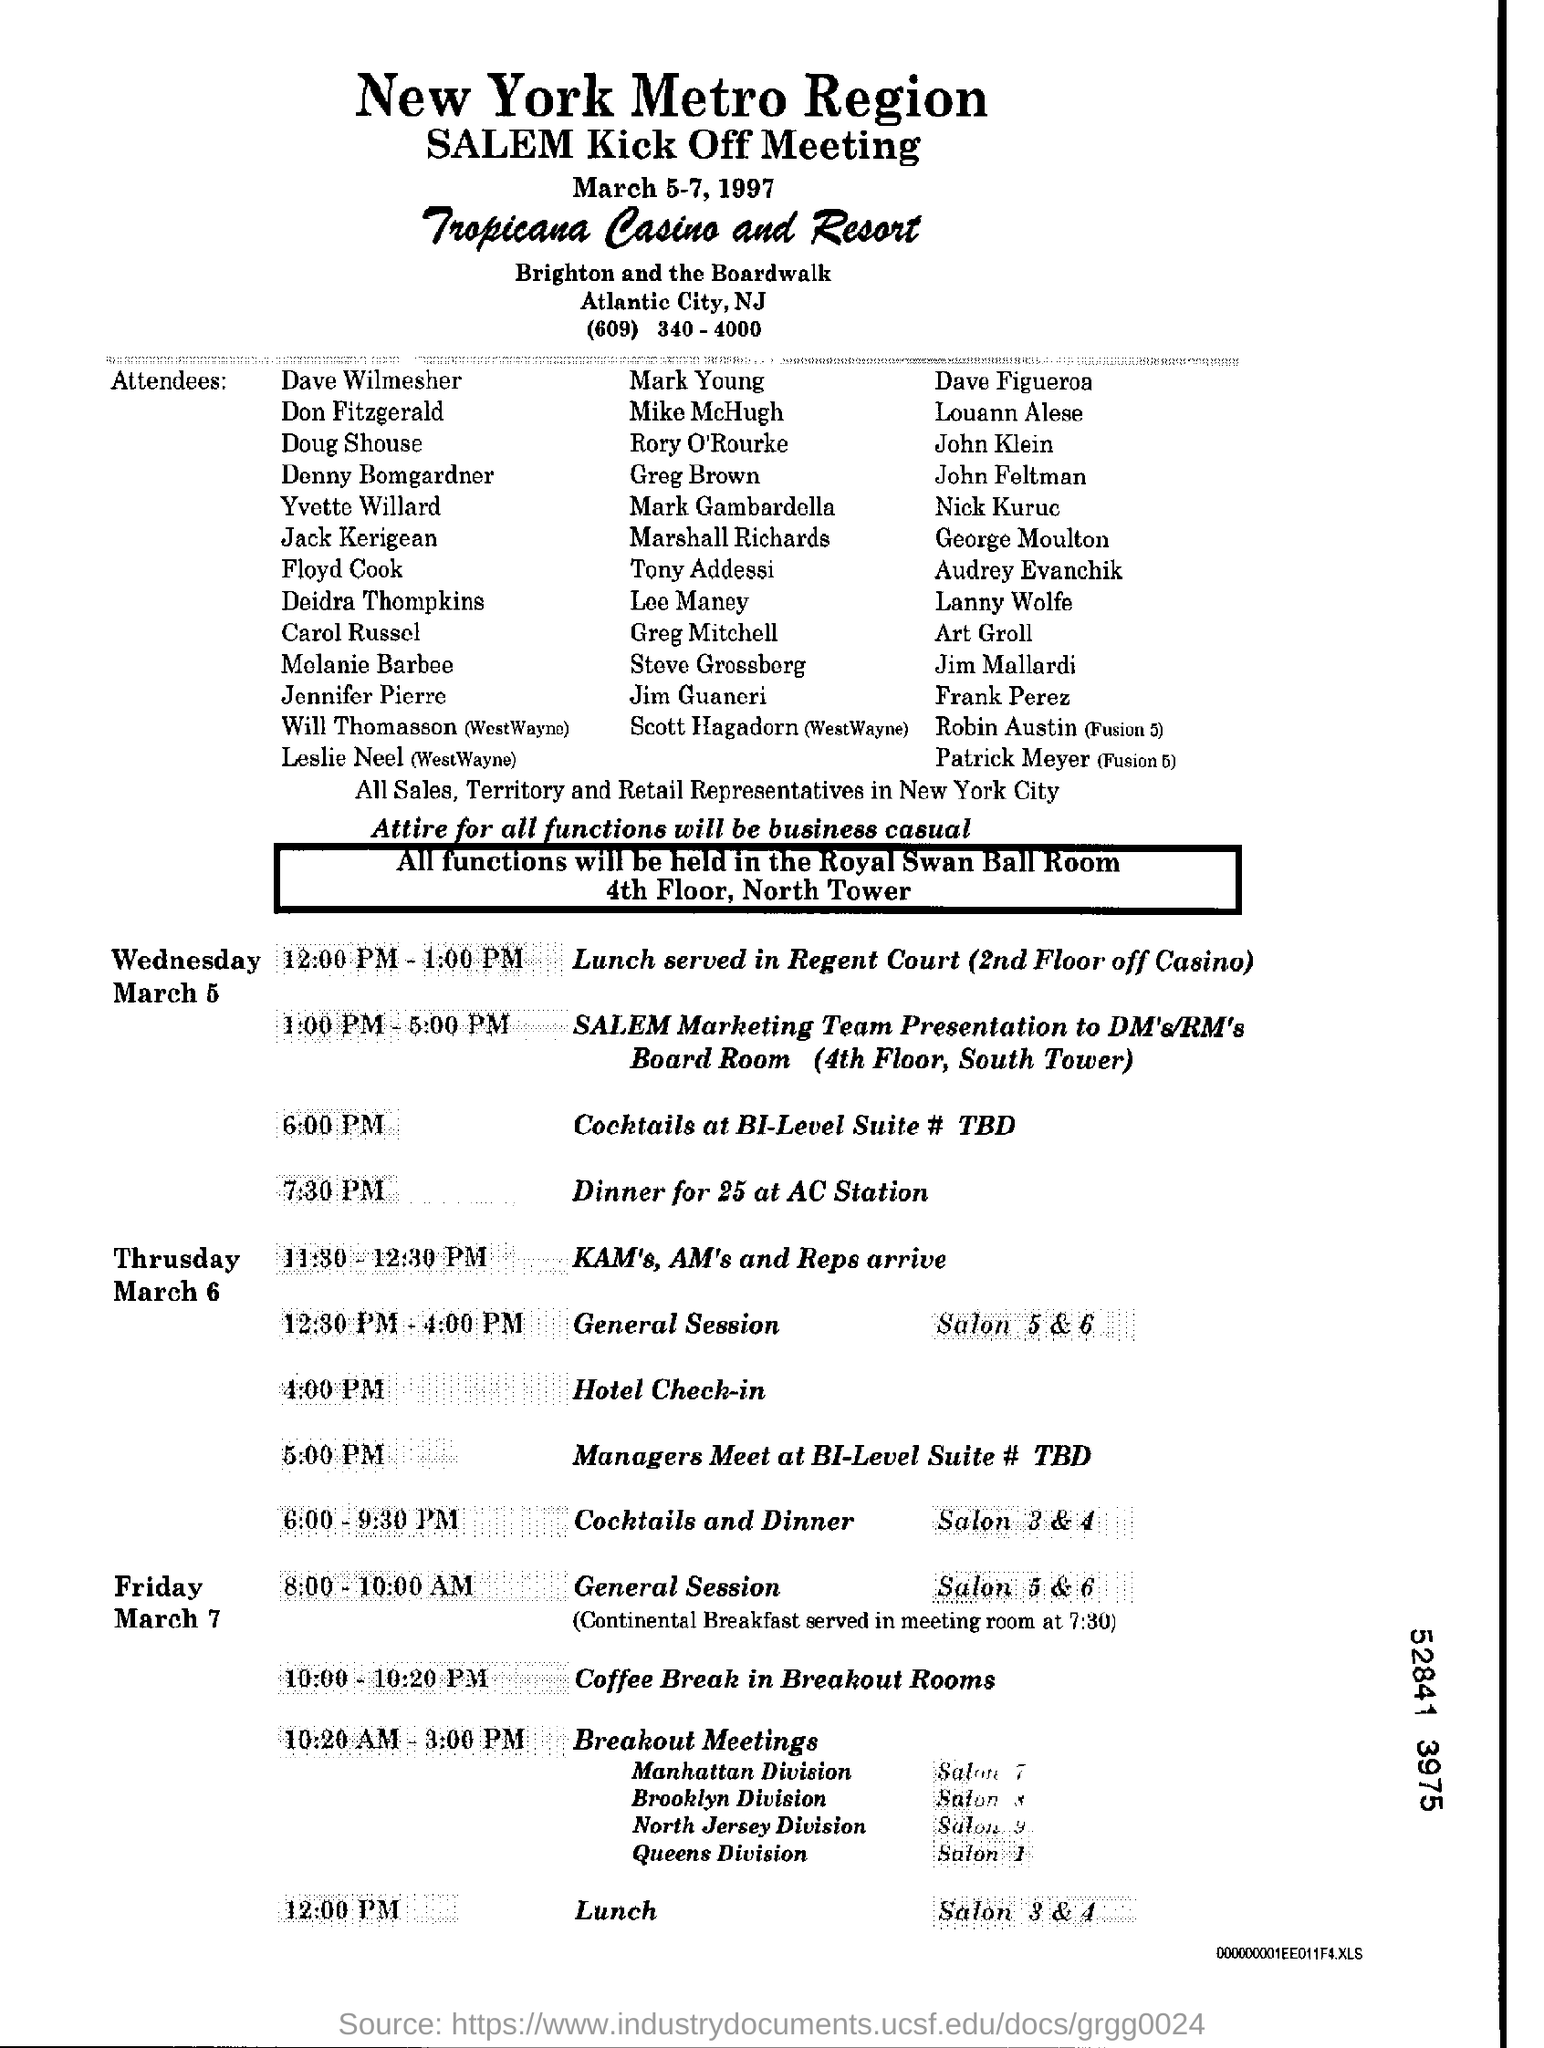Check the image and answer the question given in the input text.

What is the Lunch Time of Friday ? The Lunch Time on Friday, according to the schedule in the image, is at 12:00 PM. 